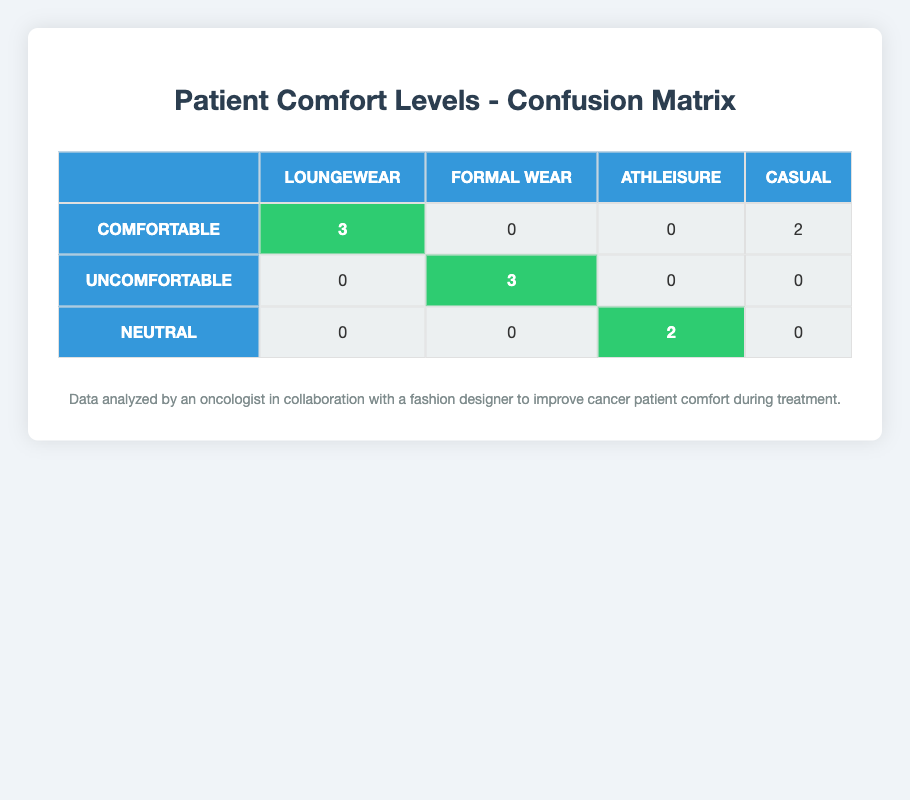What is the total number of patients who reported being comfortable in Loungewear? In the table, we look at the cell under the "Comfortable" row and "Loungewear" column. It indicates that 3 patients reported being comfortable in this clothing style.
Answer: 3 How many patients reported being uncomfortable in Formal Wear? We check the cell under the "Uncomfortable" row and "Formal Wear" column. It shows that 3 patients reported being uncomfortable in this style.
Answer: 3 What was the reported comfort level for patients wearing Athleisure? The table indicates that there are 2 patients who reported a "Neutral" comfort level while wearing Athleisure. There are no "Comfortable" or "Uncomfortable" reports given for Athleisure.
Answer: Neutral Are any patients reported as comfortable in Formal Wear? Referring to the "Comfortable" row and the "Formal Wear" column, the table shows a value of 0, indicating that no patients reported being comfortable in Formal Wear.
Answer: No What clothing style had the highest number of patients reporting comfort? To find the clothing style with the most comfortable patients, we can compare the values in the "Comfortable" row: Loungewear has 3, Formal Wear has 0, Athleisure has 0, and Casual has 2, making Loungewear the style with the highest number of patients reporting comfort.
Answer: Loungewear How many total patients reported discomfort across all clothing styles? Looking at the "Uncomfortable" row, we total the values for all clothing styles: 0 (Loungewear) + 3 (Formal Wear) + 0 (Athleisure) + 0 (Casual) = 3, indicating that there are 3 patients in total who reported discomfort in any clothing styles.
Answer: 3 What percentage of patients reported being comfortable in Casual clothing? To find the percentage, we first need to determine the total number of patients who reported comfort levels. There are 10 patients in total. The number of patients reporting comfort in Casual is 2. Therefore, the percentage is (2/10) * 100 = 20%.
Answer: 20% If we add the number of patients reporting comfortable in Casual and Loungewear, what is the total? We look at the "Comfortable" row: Casual has 2 patients, and Loungewear has 3 patients. Adding these together (2 + 3) gives us a total of 5 patients reporting comfort in these two styles.
Answer: 5 